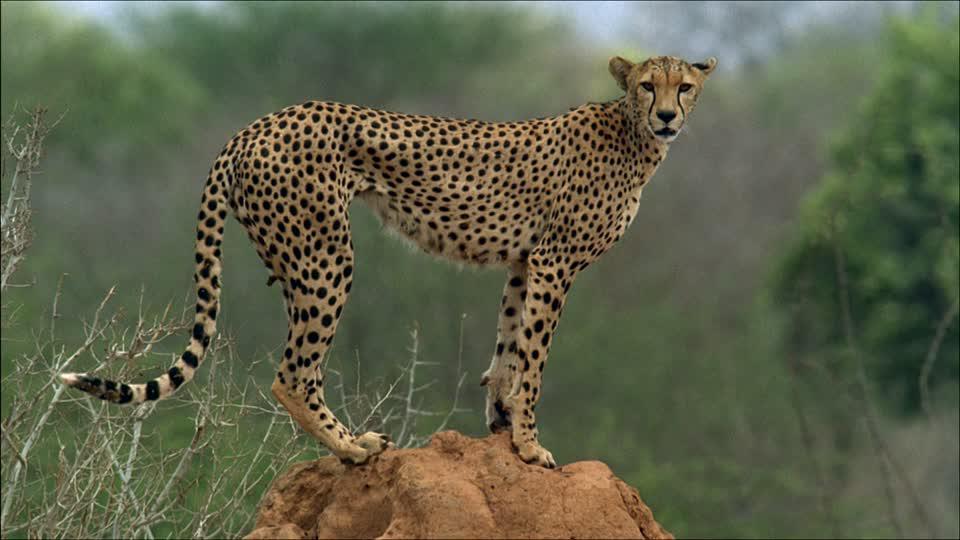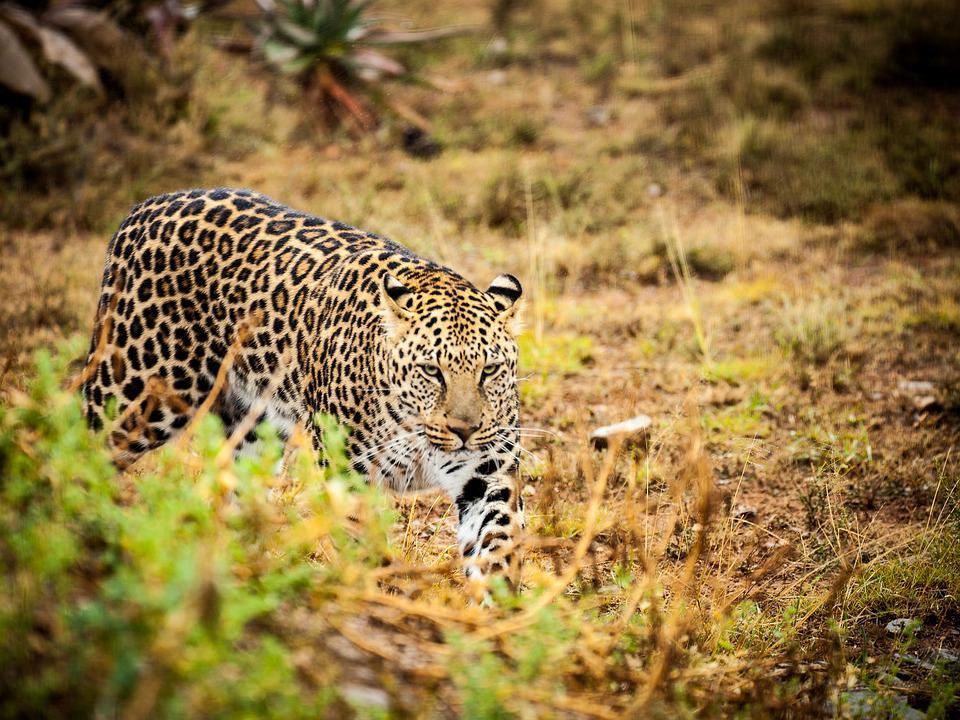The first image is the image on the left, the second image is the image on the right. For the images displayed, is the sentence "there are more than 4 cheetahs in the image pair" factually correct? Answer yes or no. No. The first image is the image on the left, the second image is the image on the right. Examine the images to the left and right. Is the description "In one image there is an adult cheetah standing over two younger cheetahs." accurate? Answer yes or no. No. 